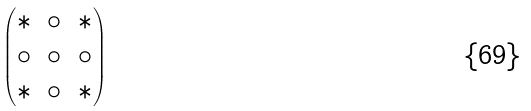<formula> <loc_0><loc_0><loc_500><loc_500>\begin{pmatrix} \ast & \circ & \ast \\ \circ & \circ & \circ \\ \ast & \circ & \ast \end{pmatrix}</formula> 